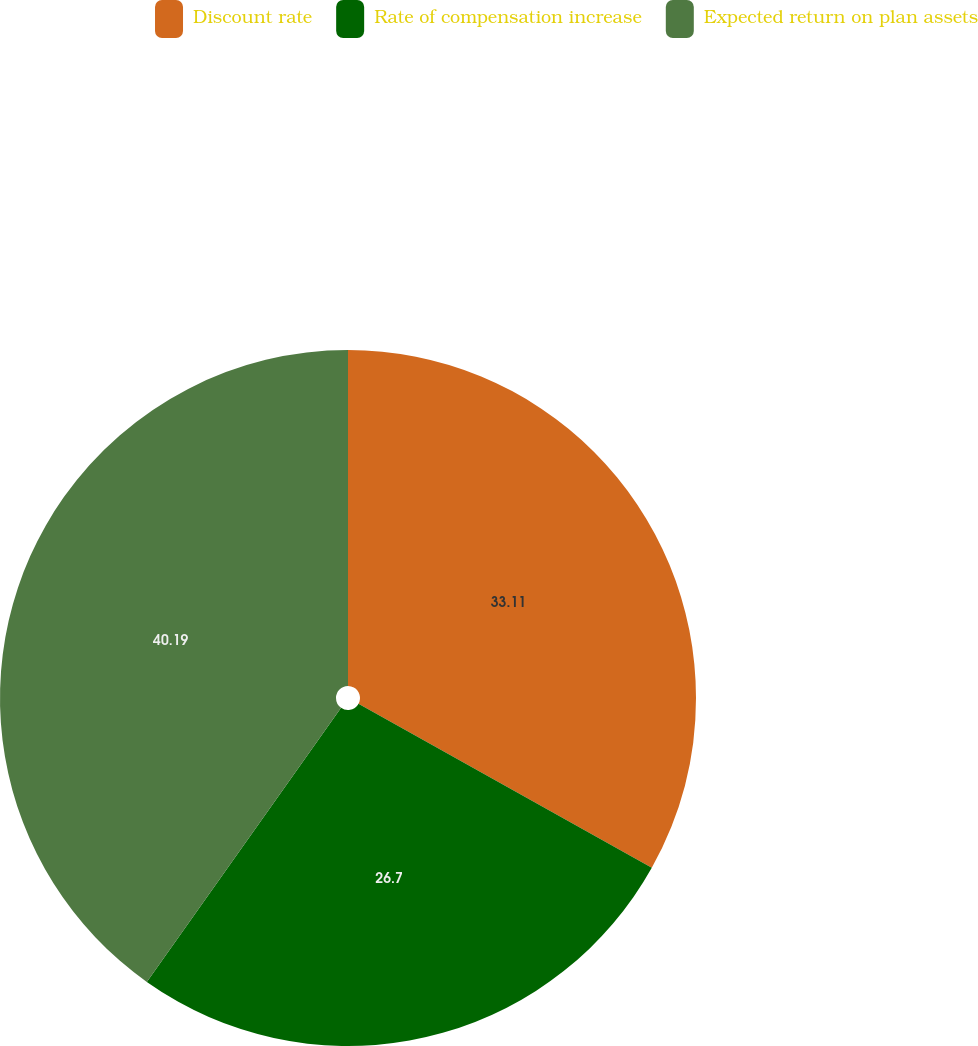<chart> <loc_0><loc_0><loc_500><loc_500><pie_chart><fcel>Discount rate<fcel>Rate of compensation increase<fcel>Expected return on plan assets<nl><fcel>33.11%<fcel>26.7%<fcel>40.19%<nl></chart> 